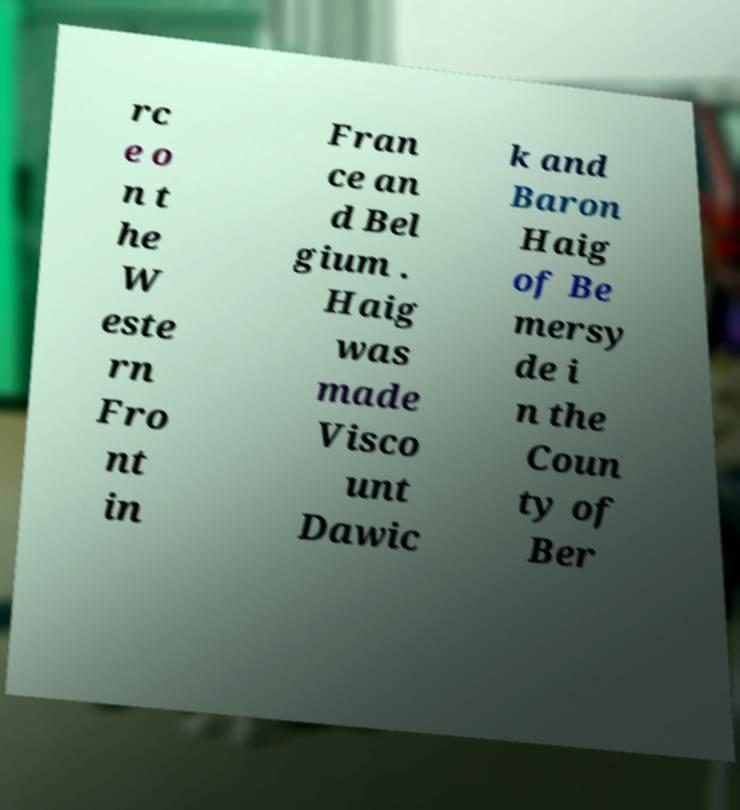Can you read and provide the text displayed in the image?This photo seems to have some interesting text. Can you extract and type it out for me? rc e o n t he W este rn Fro nt in Fran ce an d Bel gium . Haig was made Visco unt Dawic k and Baron Haig of Be mersy de i n the Coun ty of Ber 